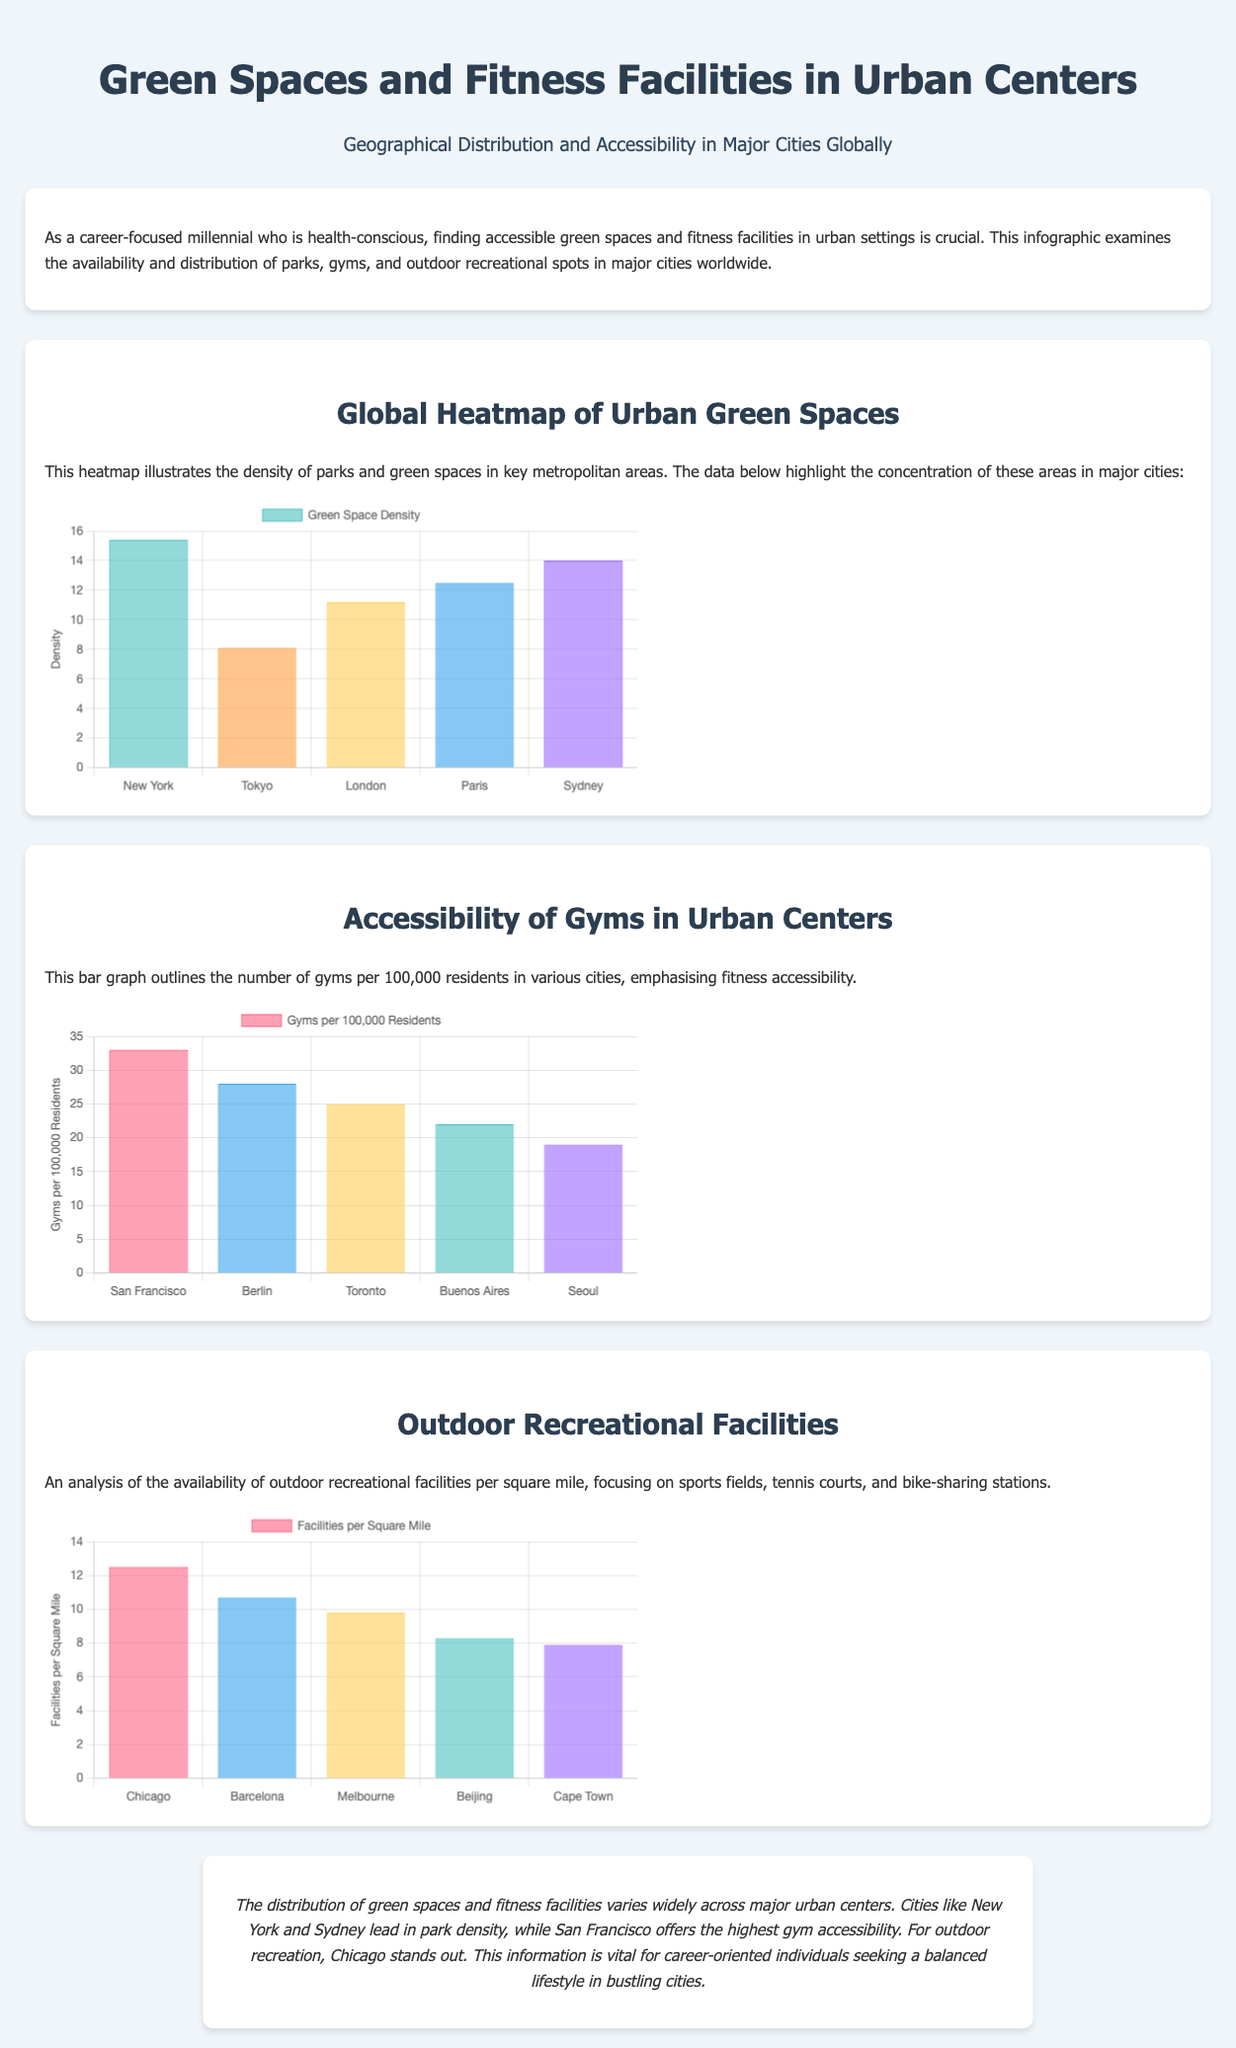What city has the highest green space density? The chart shows that New York has the highest density with a value of 15.4.
Answer: New York What is the number of gyms per 100,000 residents in San Francisco? The bar graph indicates that San Francisco has 33 gyms per 100,000 residents.
Answer: 33 Which city is noted for having the highest number of outdoor recreational facilities per square mile? Chicago is highlighted as it has the highest facilities per square mile in the document.
Answer: Chicago How many parks per square mile does Melbourne have? The document does not provide a specific number for parks in Melbourne but focuses on the number of facilities instead.
Answer: Not specified Which city ranks second in green space density? The chart indicates that Sydney ranks second with a density of 14.0.
Answer: Sydney What type of outdoor recreational facilities are mentioned? The document specifically mentions sports fields, tennis courts, and bike-sharing stations.
Answer: Sports fields, tennis courts, bike-sharing stations What is the overall trend in gym accessibility among the listed cities? The bar graph illustrates that gym accessibility is highest in San Francisco and decreases in the other cities.
Answer: Highest in San Francisco Which city is the lowest in outdoor recreational facilities per square mile? The chart indicates that Cape Town has the lowest number with a value of 7.9 facilities per square mile.
Answer: Cape Town 